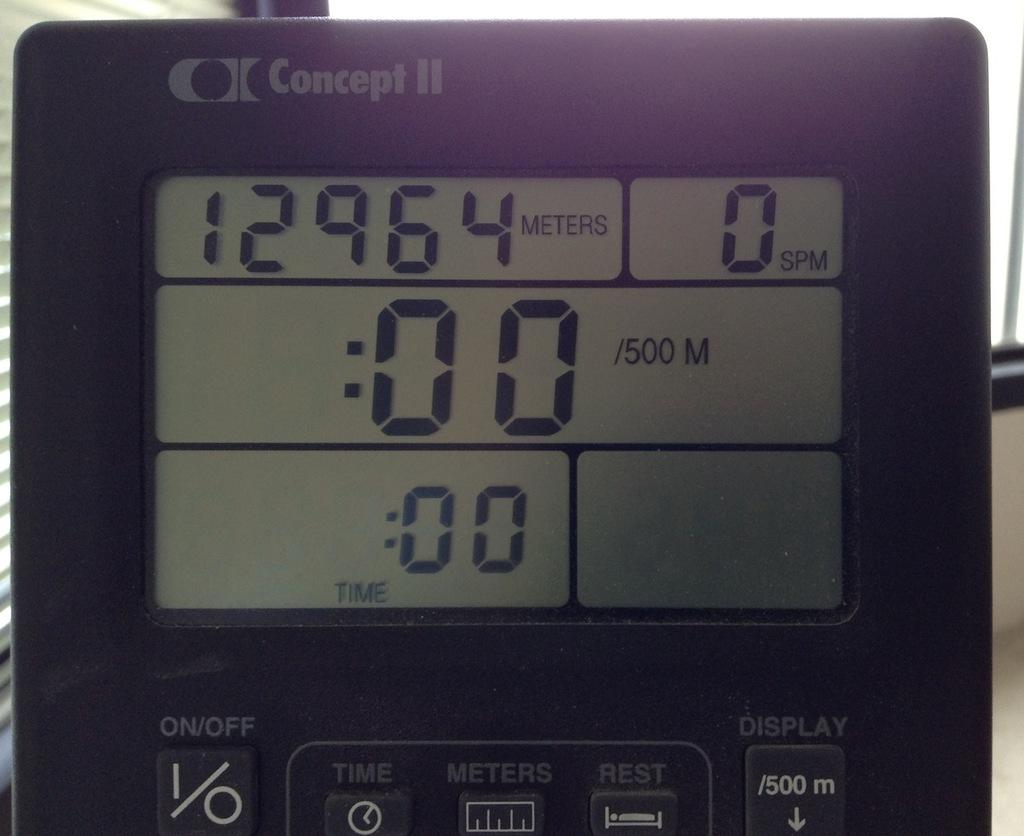What is the spm?
Keep it short and to the point. 0. How many meters?
Your answer should be very brief. 12964. 